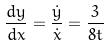<formula> <loc_0><loc_0><loc_500><loc_500>\frac { d y } { d x } = \frac { \dot { y } } { \dot { x } } = \frac { 3 } { 8 t }</formula> 